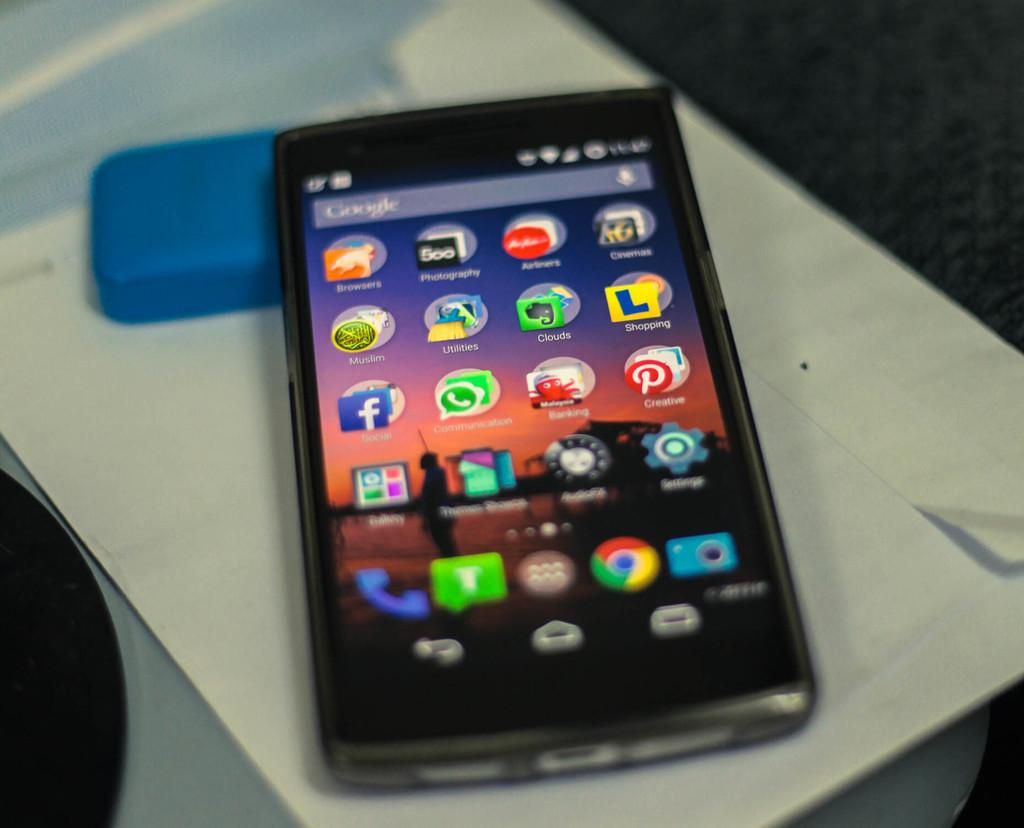<image>
Write a terse but informative summary of the picture. android phone with a google search bar at top laying on a white paper 